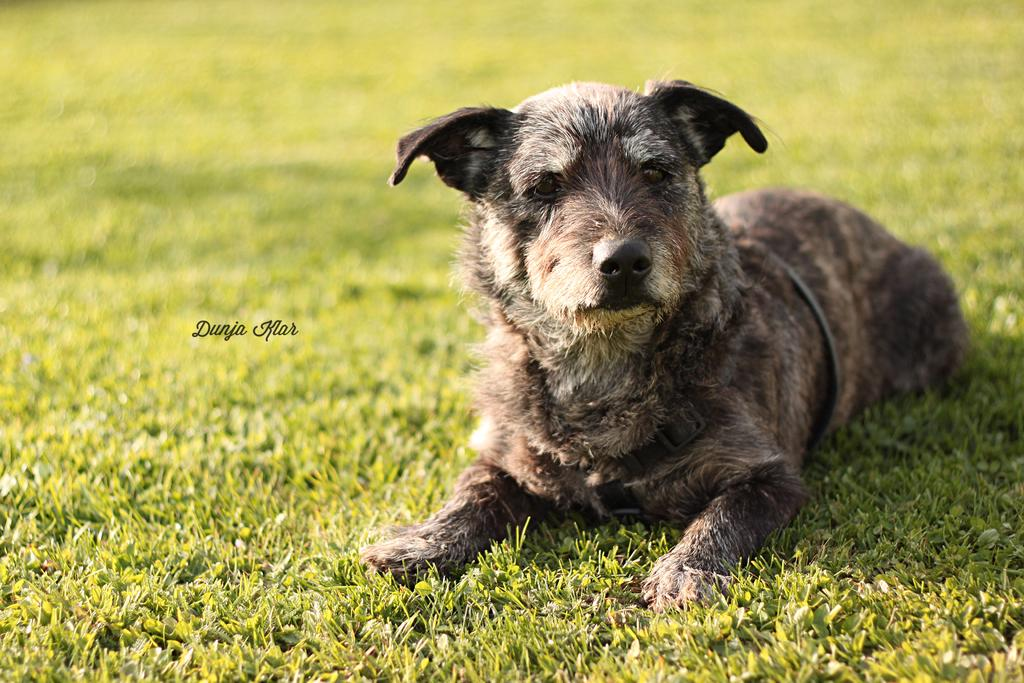What type of surface is on the ground in the image? There is grass on the ground in the image. What is the god in the image sitting on? The god is sitting on the grass. Is there any text or label in the image? Yes, there is a name in the image. What type of metal is the roof made of in the image? There is no roof present in the image, so it is not possible to determine the type of metal used for the roof. 